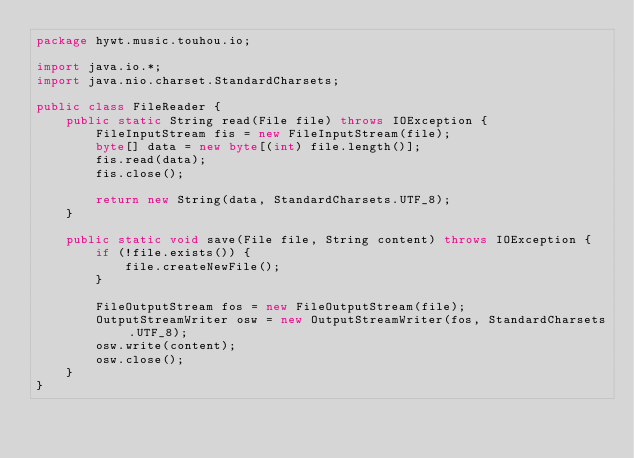Convert code to text. <code><loc_0><loc_0><loc_500><loc_500><_Java_>package hywt.music.touhou.io;

import java.io.*;
import java.nio.charset.StandardCharsets;

public class FileReader {
    public static String read(File file) throws IOException {
        FileInputStream fis = new FileInputStream(file);
        byte[] data = new byte[(int) file.length()];
        fis.read(data);
        fis.close();

        return new String(data, StandardCharsets.UTF_8);
    }

    public static void save(File file, String content) throws IOException {
        if (!file.exists()) {
            file.createNewFile();
        }

        FileOutputStream fos = new FileOutputStream(file);
        OutputStreamWriter osw = new OutputStreamWriter(fos, StandardCharsets.UTF_8);
        osw.write(content);
        osw.close();
    }
}
</code> 